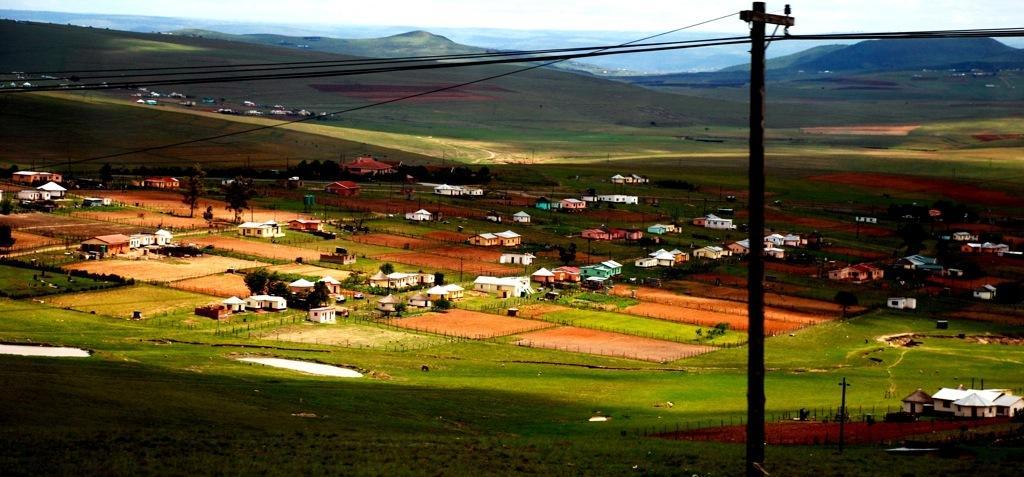Please provide a concise description of this image. In this image I can see few poles, few wires, an open grass ground and I can see number of buildings. I can also see mountains in background. 